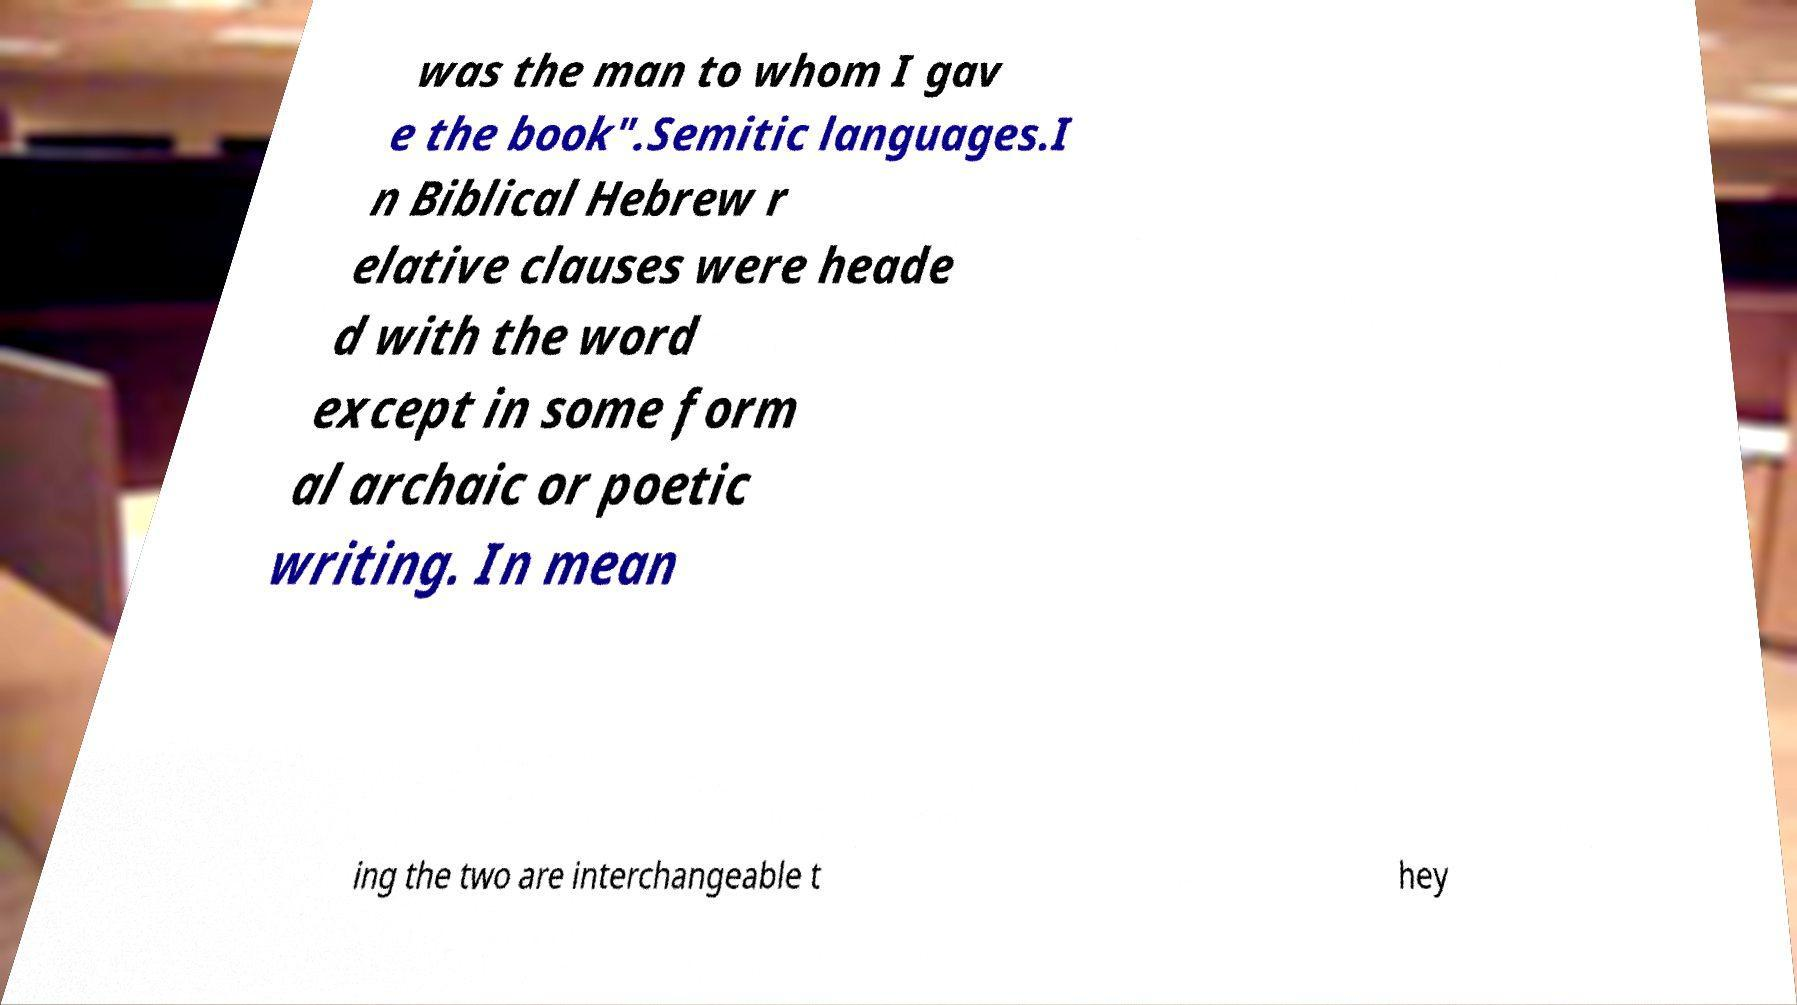Could you extract and type out the text from this image? was the man to whom I gav e the book".Semitic languages.I n Biblical Hebrew r elative clauses were heade d with the word except in some form al archaic or poetic writing. In mean ing the two are interchangeable t hey 